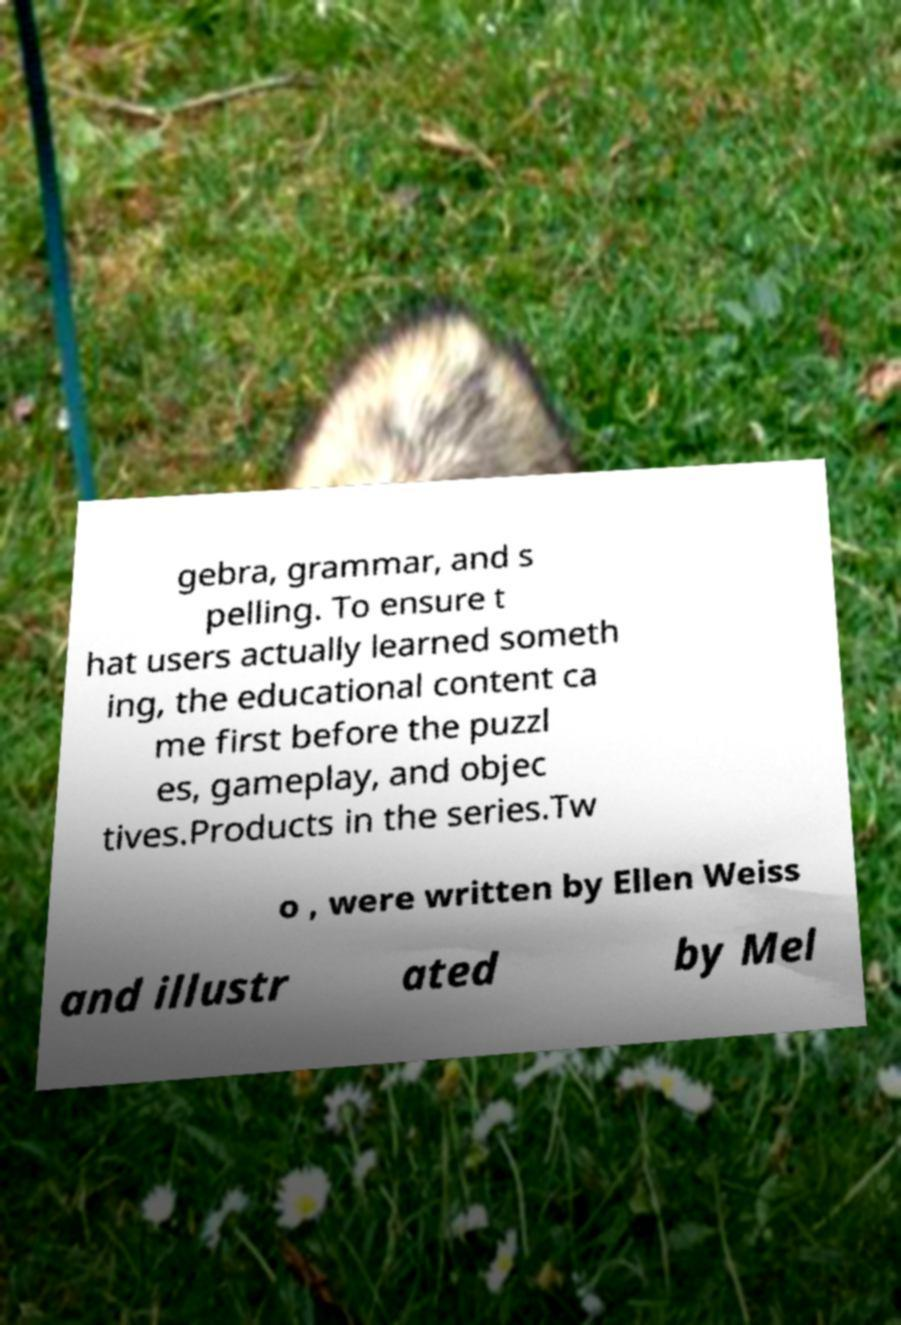Please identify and transcribe the text found in this image. gebra, grammar, and s pelling. To ensure t hat users actually learned someth ing, the educational content ca me first before the puzzl es, gameplay, and objec tives.Products in the series.Tw o , were written by Ellen Weiss and illustr ated by Mel 